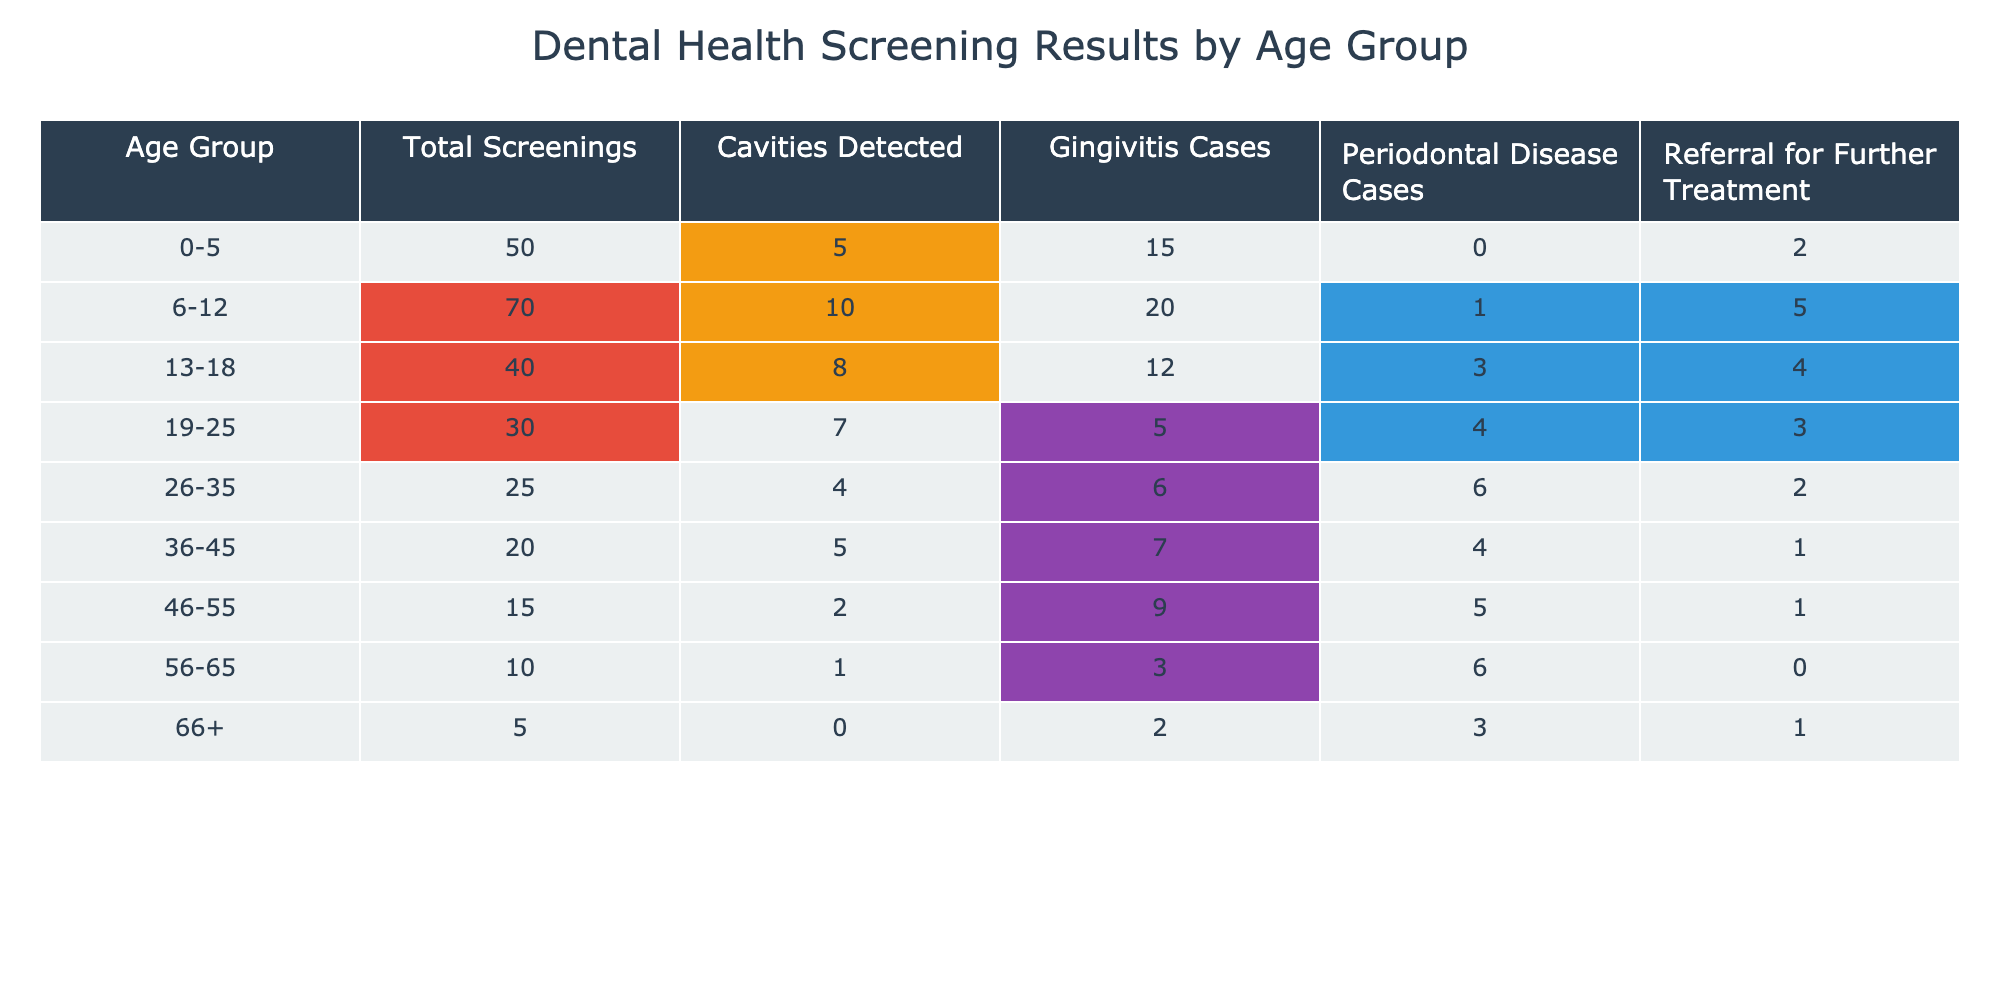What age group has the highest number of cavities detected? The table shows that the 6-12 age group has 10 cavities detected. Comparing with other groups, all other groups have fewer cavities detected (the highest after that is 8 in the 13-18 age group). Thus, the 6-12 age group has the highest number.
Answer: 6-12 How many total screenings were conducted for individuals aged 36-45? The table directly states that there were 20 total screenings conducted for individuals aged 36-45.
Answer: 20 Is it true that older age groups have fewer cases of cavities detected? Looking at the table, it's clear that the younger age group (6-12) has the highest cavities detected (10), while older groups generally have fewer, with the 66+ age group showing 0 cavities. Therefore, it can be said that older age groups usually have fewer cavities detected.
Answer: Yes What is the total number of cavities detected across all age groups? To find the total cavities detected, we sum up the values from the 'Cavities Detected' column: 5 (0-5) + 10 (6-12) + 8 (13-18) + 7 (19-25) + 4 (26-35) + 5 (36-45) + 2 (46-55) + 1 (56-65) + 0 (66+) = 42. Therefore, the total is 42.
Answer: 42 Which age group had the highest number of referrals for further treatment? By examining the 'Referral for Further Treatment' column, we see that the 6-12 age group had the highest at 5 referrals. No other age group exceeds this number.
Answer: 6-12 